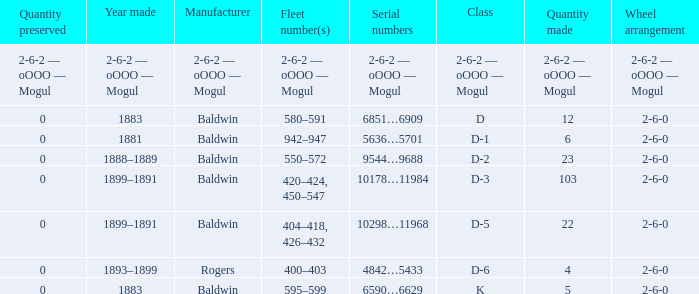What is the quantity made when the class is d-2? 23.0. 